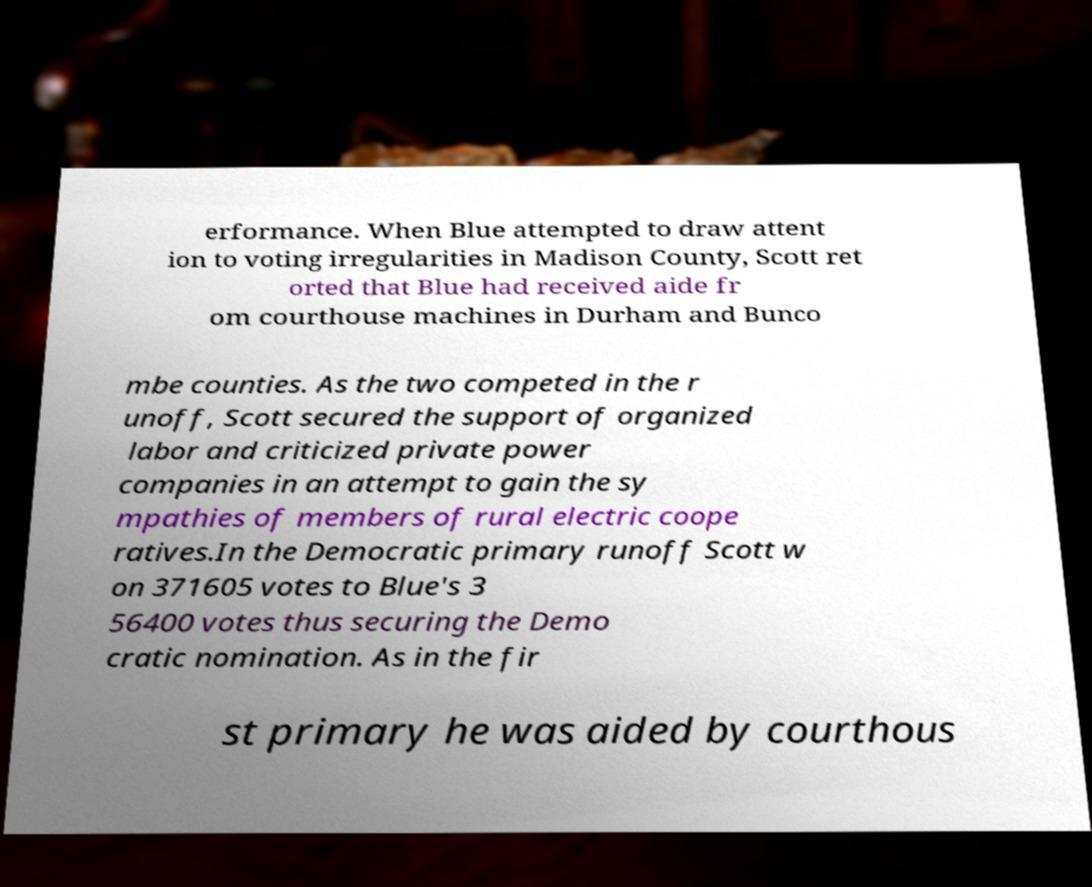There's text embedded in this image that I need extracted. Can you transcribe it verbatim? erformance. When Blue attempted to draw attent ion to voting irregularities in Madison County, Scott ret orted that Blue had received aide fr om courthouse machines in Durham and Bunco mbe counties. As the two competed in the r unoff, Scott secured the support of organized labor and criticized private power companies in an attempt to gain the sy mpathies of members of rural electric coope ratives.In the Democratic primary runoff Scott w on 371605 votes to Blue's 3 56400 votes thus securing the Demo cratic nomination. As in the fir st primary he was aided by courthous 